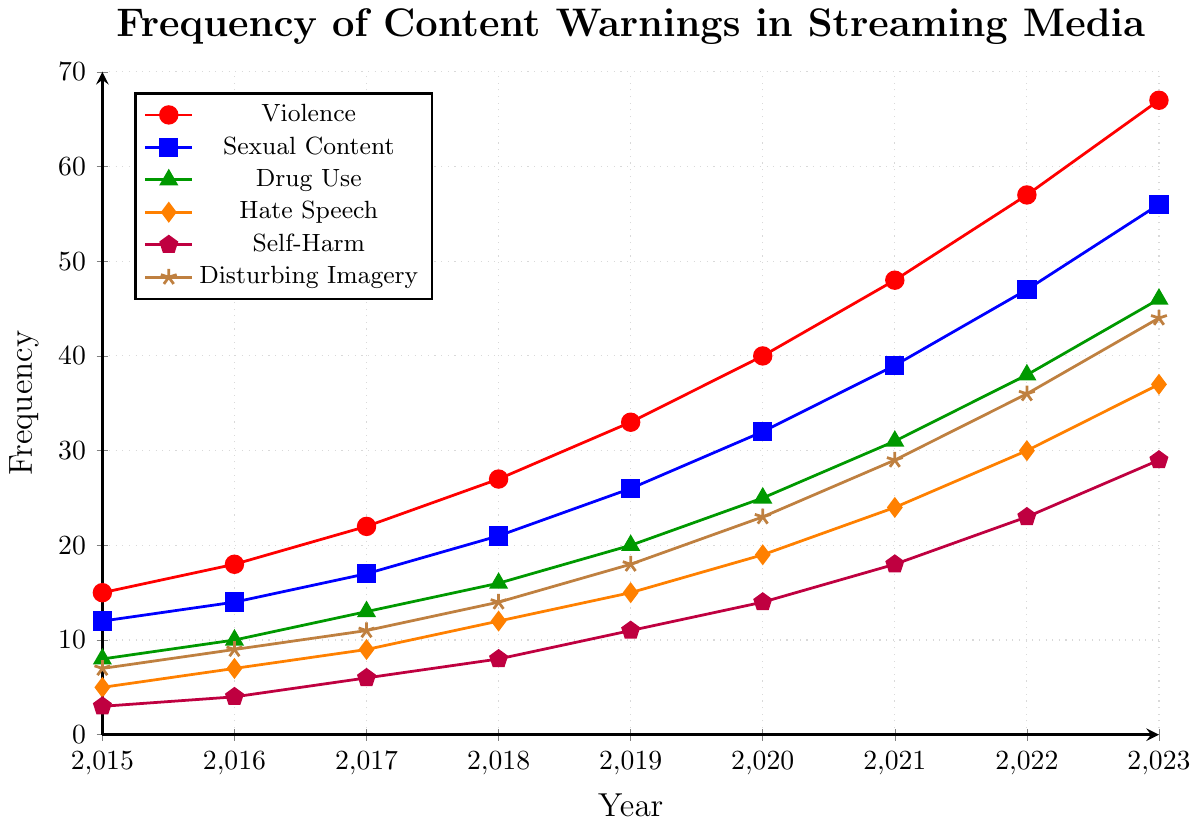What type of potentially sensitive material had the highest frequency in 2023? Look at the 2023 values and identify which category has the highest number. The "Violence" category had the highest frequency with a value of 67.
Answer: Violence What is the sum of frequencies for Drug Use and Hate Speech in 2019? Add the values for Drug Use (20) and Hate Speech (15) in 2019. The sum is 20 + 15 = 35.
Answer: 35 Between 2018 and 2023, which sensitive material category had the highest increase in frequency? Calculate the difference in frequency for each category between 2018 and 2023. "Violence" increased from 27 to 67, so the increase is 40, which is the highest among all categories.
Answer: Violence Which category had an equal frequency of content warnings in both 2017 and 2018? Compare the frequencies for all categories between 2017 and 2018. There is no category with the same frequency for both years.
Answer: None In which year did Self-Harm warnings show a double-digit increase compared to the previous year for the first time? Check the yearly differences for Self-Harm warnings. From 2021 to 2022, the increase was from 18 to 23 (an increase of 5), and from 2022 to 2023, the increase was from 23 to 29 (an increase of 6). No double-digit increase is observed.
Answer: Never What is the average frequency of Sexual Content warnings from 2015 to 2019? Add the values of Sexual Content warnings from 2015 to 2019 and then divide by the number of years. The sum is 12 + 14 + 17 + 21 + 26 = 90; the average is 90 / 5 = 18.
Answer: 18 By how much did Disturbing Imagery warnings increase from 2015 to 2023? Subtract the 2015 value from the 2023 value for Disturbing Imagery. The increase is 44 - 7 = 37.
Answer: 37 Which category had the least increase in frequency from 2020 to 2021? Calculate the increase for each category from 2020 to 2021. Self-Harm increased from 14 to 18 (an increase of 4), which is the least.
Answer: Self-Harm What was the frequency of Hate Speech warnings relative to Sexual Content warnings in 2016? Divide the frequency of Hate Speech warnings by the frequency of Sexual Content warnings in 2016. The relative frequency is 7 / 14 = 0.5.
Answer: 0.5 Which category had its frequency double from 2018 to 2023? Compare the frequencies of each category from 2018 to 2023 and check if any category doubled its frequency. Hate Speech increased from 12 to 37, which is more than double but not exactly double for the simpler case. Drug Use increased from 16 to 46 which is close but not exact either. No precise double was observed.
Answer: None 